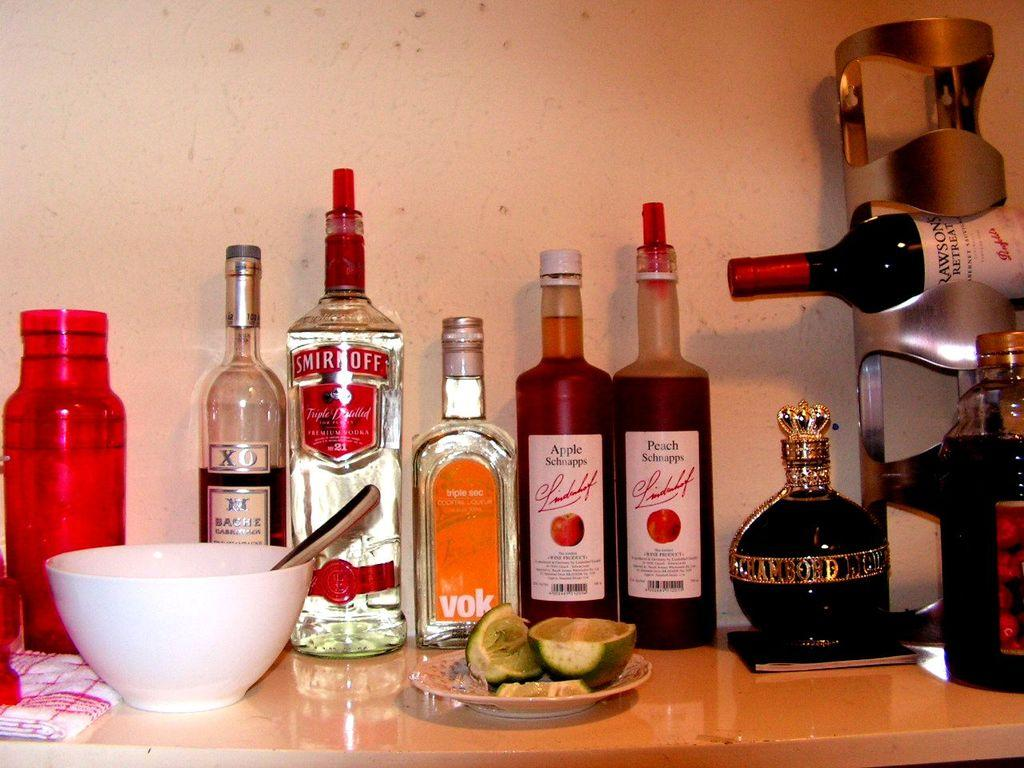<image>
Present a compact description of the photo's key features. Several bottles of alchohol including Smirnoff, Apple Schnapps, and Peach Schnapps are lined up against a wall. 